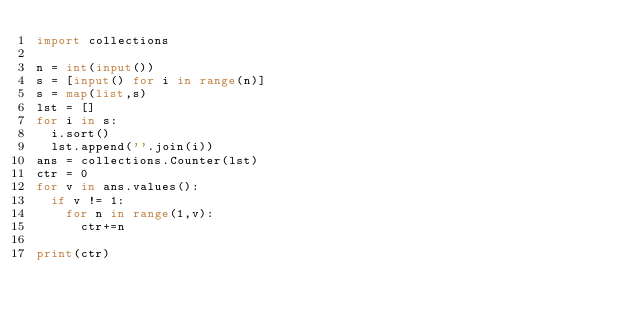Convert code to text. <code><loc_0><loc_0><loc_500><loc_500><_Python_>import collections

n = int(input())
s = [input() for i in range(n)]
s = map(list,s)
lst = []
for i in s:
  i.sort()
  lst.append(''.join(i))
ans = collections.Counter(lst)
ctr = 0
for v in ans.values():
  if v != 1:
    for n in range(1,v):
      ctr+=n
      
print(ctr)</code> 